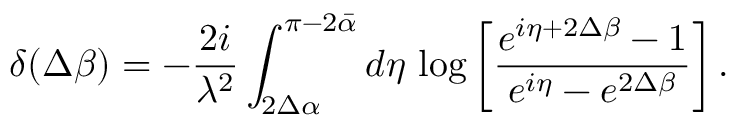Convert formula to latex. <formula><loc_0><loc_0><loc_500><loc_500>\delta ( \Delta \beta ) = - \frac { 2 i } { \lambda ^ { 2 } } \int _ { 2 \Delta \alpha } ^ { \pi - 2 \bar { \alpha } } d \eta \, \log \left [ \frac { e ^ { i \eta + 2 \Delta \beta } - 1 } { e ^ { i \eta } - e ^ { 2 \Delta \beta } } \right ] .</formula> 